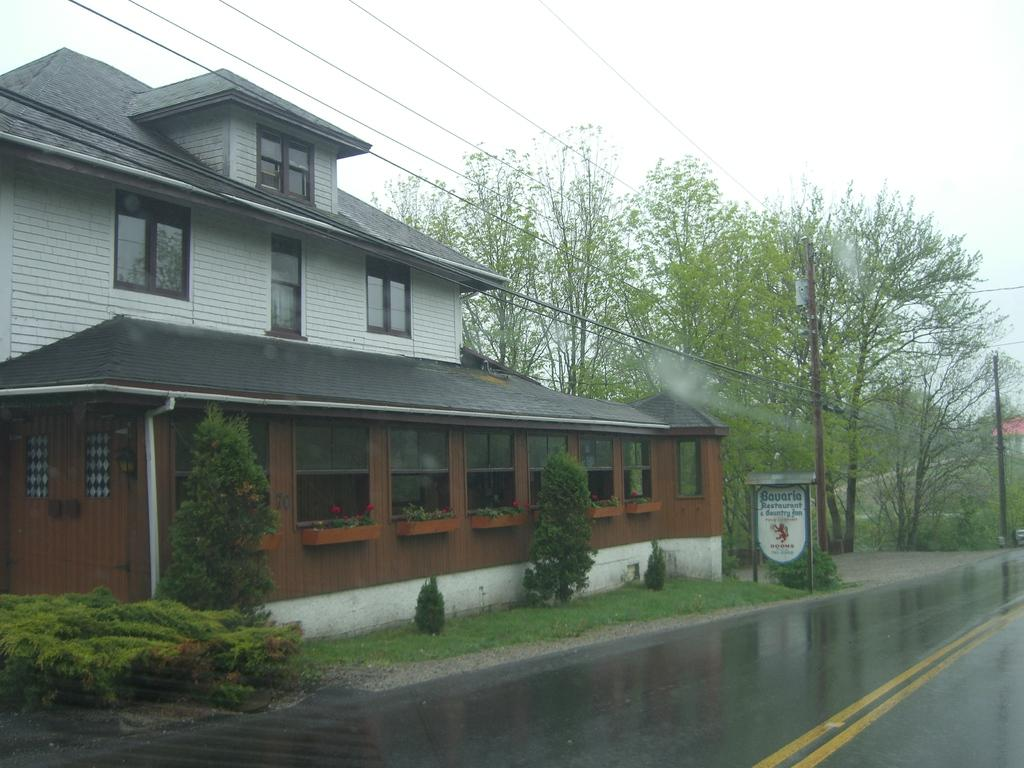What type of structure is in the image? There is a house in the image. What can be seen around the house? There are many trees and grass around the house. Is there any indication of a nearby road? Yes, there is a road beside the house. How does the road appear in the image? The road is empty and wet. What type of adjustment does the house need to make to accommodate the mouth in the image? There is no mouth present in the image, so no adjustment is necessary. 